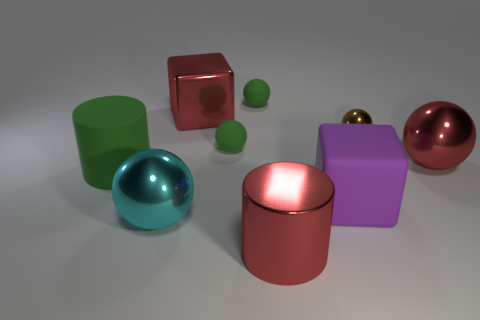Does the cylinder that is left of the large red metallic cylinder have the same color as the rubber ball behind the red shiny cube?
Your answer should be compact. Yes. Is the tiny green ball that is behind the big red metal block made of the same material as the large red cube?
Keep it short and to the point. No. How many other things are there of the same shape as the brown metal thing?
Provide a short and direct response. 4. What number of objects are left of the large red metal object that is on the left side of the big thing in front of the cyan shiny thing?
Your answer should be compact. 2. There is a large sphere that is on the left side of the large purple rubber cube; what color is it?
Provide a succinct answer. Cyan. There is a large metallic object in front of the cyan sphere; is its color the same as the small shiny object?
Ensure brevity in your answer.  No. The brown shiny object that is the same shape as the large cyan shiny thing is what size?
Make the answer very short. Small. There is a green thing that is in front of the large shiny ball to the right of the thing that is in front of the large cyan metal ball; what is it made of?
Give a very brief answer. Rubber. Is the number of large green cylinders that are to the left of the brown ball greater than the number of large cyan things that are right of the red cylinder?
Make the answer very short. Yes. Do the cyan metal object and the brown metal sphere have the same size?
Offer a very short reply. No. 